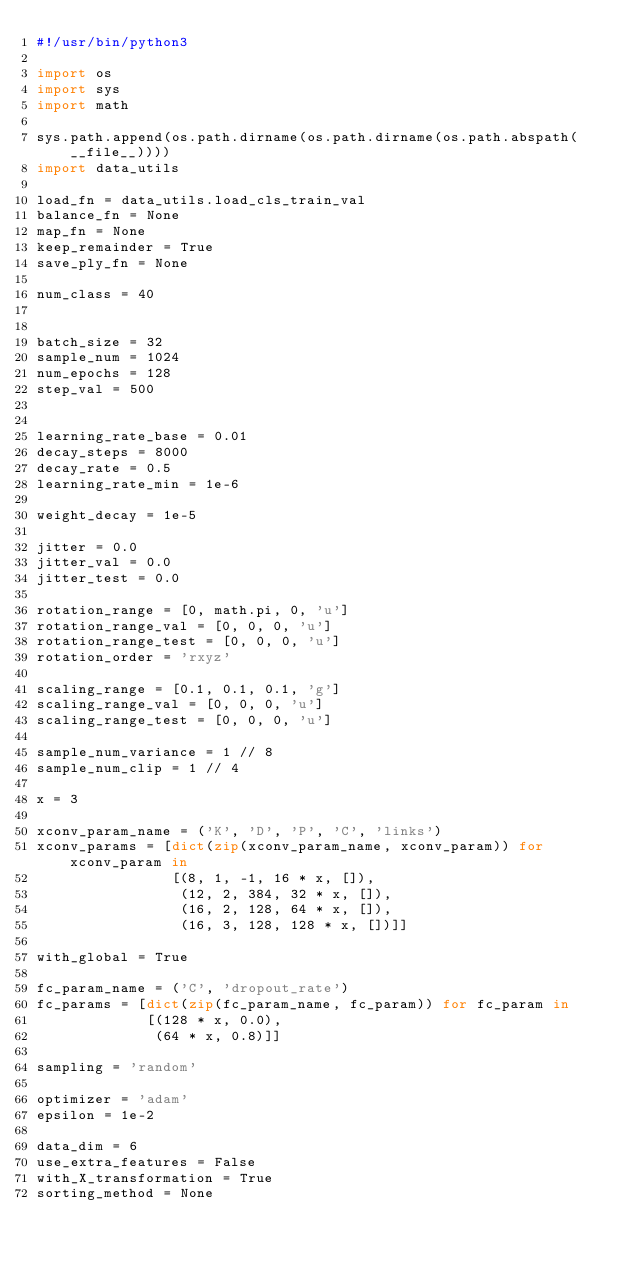<code> <loc_0><loc_0><loc_500><loc_500><_Python_>#!/usr/bin/python3

import os
import sys
import math

sys.path.append(os.path.dirname(os.path.dirname(os.path.abspath(__file__))))
import data_utils

load_fn = data_utils.load_cls_train_val
balance_fn = None
map_fn = None
keep_remainder = True
save_ply_fn = None

num_class = 40


batch_size = 32
sample_num = 1024
num_epochs = 128
step_val = 500


learning_rate_base = 0.01
decay_steps = 8000
decay_rate = 0.5
learning_rate_min = 1e-6

weight_decay = 1e-5

jitter = 0.0
jitter_val = 0.0
jitter_test = 0.0

rotation_range = [0, math.pi, 0, 'u']
rotation_range_val = [0, 0, 0, 'u']
rotation_range_test = [0, 0, 0, 'u']
rotation_order = 'rxyz'

scaling_range = [0.1, 0.1, 0.1, 'g']
scaling_range_val = [0, 0, 0, 'u']
scaling_range_test = [0, 0, 0, 'u']

sample_num_variance = 1 // 8
sample_num_clip = 1 // 4

x = 3

xconv_param_name = ('K', 'D', 'P', 'C', 'links')
xconv_params = [dict(zip(xconv_param_name, xconv_param)) for xconv_param in
                [(8, 1, -1, 16 * x, []),
                 (12, 2, 384, 32 * x, []),
                 (16, 2, 128, 64 * x, []),
                 (16, 3, 128, 128 * x, [])]]

with_global = True

fc_param_name = ('C', 'dropout_rate')
fc_params = [dict(zip(fc_param_name, fc_param)) for fc_param in
             [(128 * x, 0.0),
              (64 * x, 0.8)]]

sampling = 'random'

optimizer = 'adam'
epsilon = 1e-2

data_dim = 6
use_extra_features = False
with_X_transformation = True
sorting_method = None
</code> 